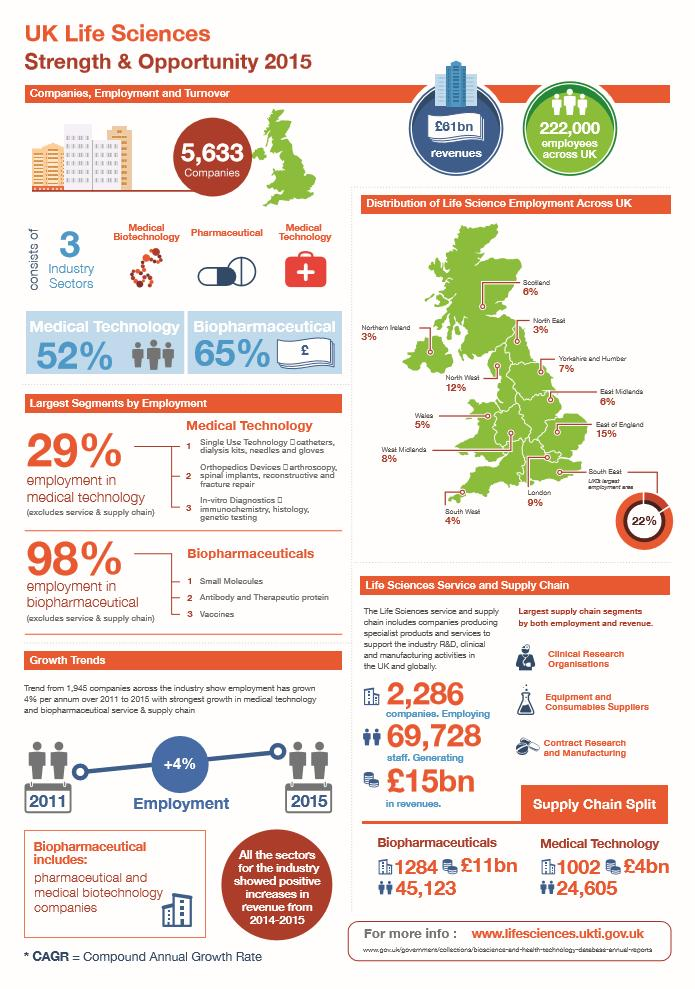Indicate a few pertinent items in this graphic. According to information from 2015, the revenue generated by life science services in the UK was estimated to be approximately 15 billion British pounds. In 2015, just 3% of life science employment was located in Northern Ireland. There were 1,284 biopharmaceutical companies operating in the UK in 2015. In 2015, there were 2,286 life science services and supply chain companies operating in the United Kingdom. Biopharmaceutical companies in the UK generated a total revenue of approximately £11 billion in 2015. 